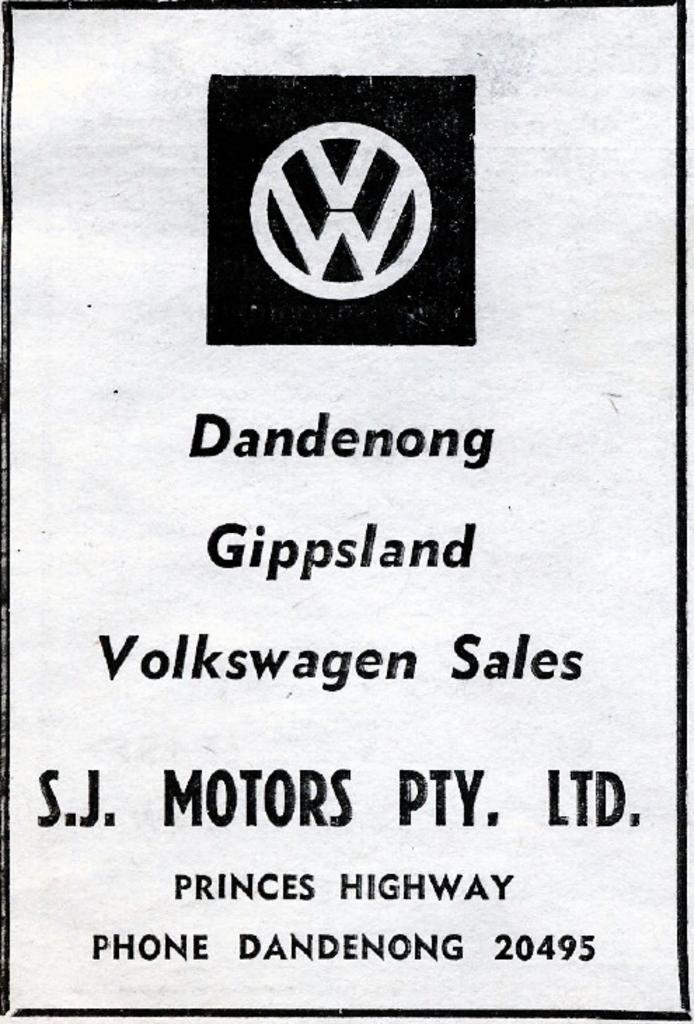<image>
Describe the image concisely. A black and white ad for Volkswagen Sales. 